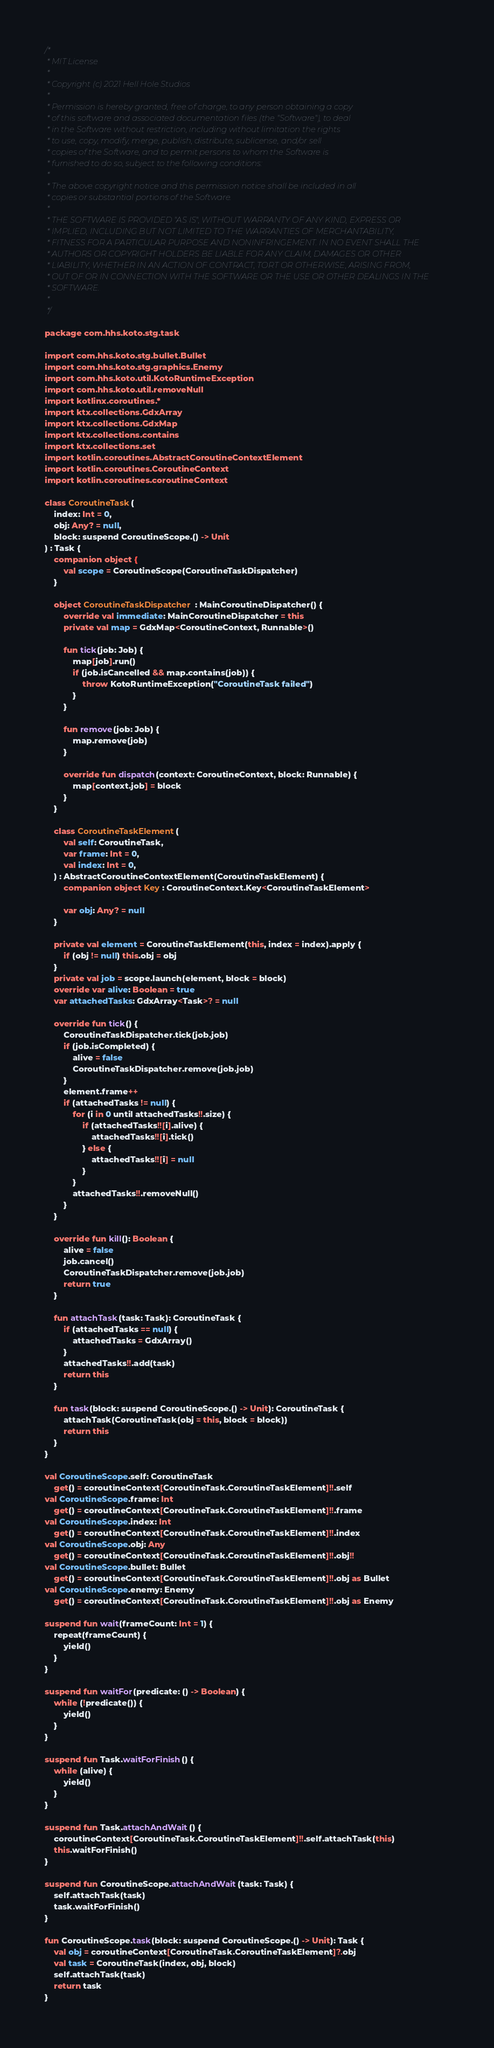Convert code to text. <code><loc_0><loc_0><loc_500><loc_500><_Kotlin_>/*
 * MIT License
 *
 * Copyright (c) 2021 Hell Hole Studios
 *
 * Permission is hereby granted, free of charge, to any person obtaining a copy
 * of this software and associated documentation files (the "Software"), to deal
 * in the Software without restriction, including without limitation the rights
 * to use, copy, modify, merge, publish, distribute, sublicense, and/or sell
 * copies of the Software, and to permit persons to whom the Software is
 * furnished to do so, subject to the following conditions:
 *
 * The above copyright notice and this permission notice shall be included in all
 * copies or substantial portions of the Software.
 *
 * THE SOFTWARE IS PROVIDED "AS IS", WITHOUT WARRANTY OF ANY KIND, EXPRESS OR
 * IMPLIED, INCLUDING BUT NOT LIMITED TO THE WARRANTIES OF MERCHANTABILITY,
 * FITNESS FOR A PARTICULAR PURPOSE AND NONINFRINGEMENT. IN NO EVENT SHALL THE
 * AUTHORS OR COPYRIGHT HOLDERS BE LIABLE FOR ANY CLAIM, DAMAGES OR OTHER
 * LIABILITY, WHETHER IN AN ACTION OF CONTRACT, TORT OR OTHERWISE, ARISING FROM,
 * OUT OF OR IN CONNECTION WITH THE SOFTWARE OR THE USE OR OTHER DEALINGS IN THE
 * SOFTWARE.
 *
 */

package com.hhs.koto.stg.task

import com.hhs.koto.stg.bullet.Bullet
import com.hhs.koto.stg.graphics.Enemy
import com.hhs.koto.util.KotoRuntimeException
import com.hhs.koto.util.removeNull
import kotlinx.coroutines.*
import ktx.collections.GdxArray
import ktx.collections.GdxMap
import ktx.collections.contains
import ktx.collections.set
import kotlin.coroutines.AbstractCoroutineContextElement
import kotlin.coroutines.CoroutineContext
import kotlin.coroutines.coroutineContext

class CoroutineTask(
    index: Int = 0,
    obj: Any? = null,
    block: suspend CoroutineScope.() -> Unit
) : Task {
    companion object {
        val scope = CoroutineScope(CoroutineTaskDispatcher)
    }

    object CoroutineTaskDispatcher : MainCoroutineDispatcher() {
        override val immediate: MainCoroutineDispatcher = this
        private val map = GdxMap<CoroutineContext, Runnable>()

        fun tick(job: Job) {
            map[job].run()
            if (job.isCancelled && map.contains(job)) {
                throw KotoRuntimeException("CoroutineTask failed")
            }
        }

        fun remove(job: Job) {
            map.remove(job)
        }

        override fun dispatch(context: CoroutineContext, block: Runnable) {
            map[context.job] = block
        }
    }

    class CoroutineTaskElement(
        val self: CoroutineTask,
        var frame: Int = 0,
        val index: Int = 0,
    ) : AbstractCoroutineContextElement(CoroutineTaskElement) {
        companion object Key : CoroutineContext.Key<CoroutineTaskElement>

        var obj: Any? = null
    }

    private val element = CoroutineTaskElement(this, index = index).apply {
        if (obj != null) this.obj = obj
    }
    private val job = scope.launch(element, block = block)
    override var alive: Boolean = true
    var attachedTasks: GdxArray<Task>? = null

    override fun tick() {
        CoroutineTaskDispatcher.tick(job.job)
        if (job.isCompleted) {
            alive = false
            CoroutineTaskDispatcher.remove(job.job)
        }
        element.frame++
        if (attachedTasks != null) {
            for (i in 0 until attachedTasks!!.size) {
                if (attachedTasks!![i].alive) {
                    attachedTasks!![i].tick()
                } else {
                    attachedTasks!![i] = null
                }
            }
            attachedTasks!!.removeNull()
        }
    }

    override fun kill(): Boolean {
        alive = false
        job.cancel()
        CoroutineTaskDispatcher.remove(job.job)
        return true
    }

    fun attachTask(task: Task): CoroutineTask {
        if (attachedTasks == null) {
            attachedTasks = GdxArray()
        }
        attachedTasks!!.add(task)
        return this
    }

    fun task(block: suspend CoroutineScope.() -> Unit): CoroutineTask {
        attachTask(CoroutineTask(obj = this, block = block))
        return this
    }
}

val CoroutineScope.self: CoroutineTask
    get() = coroutineContext[CoroutineTask.CoroutineTaskElement]!!.self
val CoroutineScope.frame: Int
    get() = coroutineContext[CoroutineTask.CoroutineTaskElement]!!.frame
val CoroutineScope.index: Int
    get() = coroutineContext[CoroutineTask.CoroutineTaskElement]!!.index
val CoroutineScope.obj: Any
    get() = coroutineContext[CoroutineTask.CoroutineTaskElement]!!.obj!!
val CoroutineScope.bullet: Bullet
    get() = coroutineContext[CoroutineTask.CoroutineTaskElement]!!.obj as Bullet
val CoroutineScope.enemy: Enemy
    get() = coroutineContext[CoroutineTask.CoroutineTaskElement]!!.obj as Enemy

suspend fun wait(frameCount: Int = 1) {
    repeat(frameCount) {
        yield()
    }
}

suspend fun waitFor(predicate: () -> Boolean) {
    while (!predicate()) {
        yield()
    }
}

suspend fun Task.waitForFinish() {
    while (alive) {
        yield()
    }
}

suspend fun Task.attachAndWait() {
    coroutineContext[CoroutineTask.CoroutineTaskElement]!!.self.attachTask(this)
    this.waitForFinish()
}

suspend fun CoroutineScope.attachAndWait(task: Task) {
    self.attachTask(task)
    task.waitForFinish()
}

fun CoroutineScope.task(block: suspend CoroutineScope.() -> Unit): Task {
    val obj = coroutineContext[CoroutineTask.CoroutineTaskElement]?.obj
    val task = CoroutineTask(index, obj, block)
    self.attachTask(task)
    return task
}</code> 